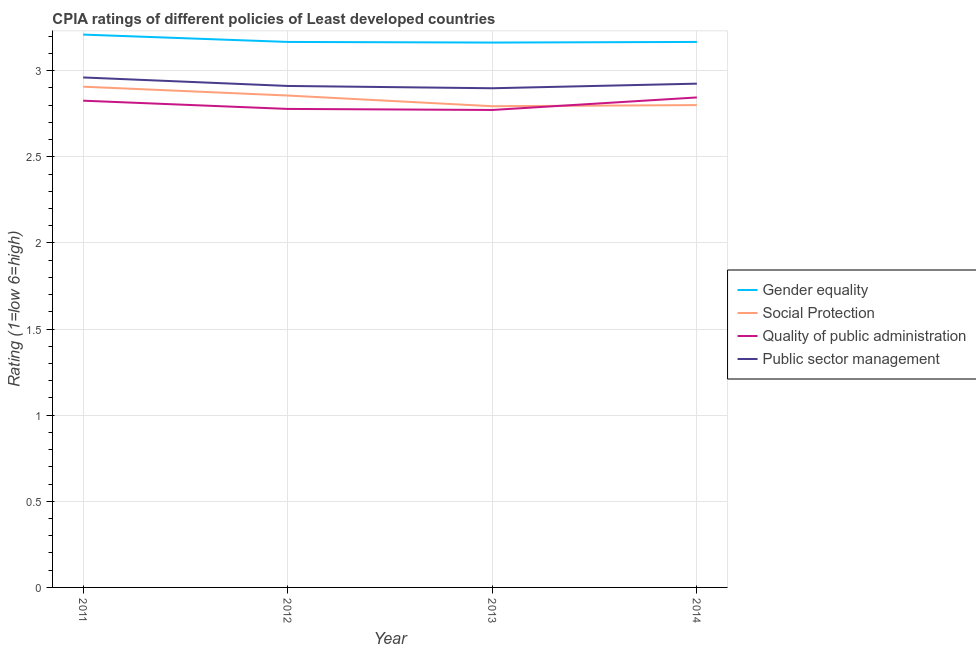Is the number of lines equal to the number of legend labels?
Make the answer very short. Yes. What is the cpia rating of quality of public administration in 2014?
Offer a terse response. 2.84. Across all years, what is the maximum cpia rating of social protection?
Keep it short and to the point. 2.91. Across all years, what is the minimum cpia rating of social protection?
Your response must be concise. 2.79. What is the total cpia rating of gender equality in the graph?
Your answer should be compact. 12.71. What is the difference between the cpia rating of social protection in 2012 and that in 2014?
Keep it short and to the point. 0.06. What is the difference between the cpia rating of quality of public administration in 2011 and the cpia rating of social protection in 2012?
Provide a succinct answer. -0.03. What is the average cpia rating of social protection per year?
Give a very brief answer. 2.84. In the year 2013, what is the difference between the cpia rating of public sector management and cpia rating of social protection?
Make the answer very short. 0.1. In how many years, is the cpia rating of social protection greater than 1.2?
Offer a very short reply. 4. What is the ratio of the cpia rating of public sector management in 2012 to that in 2014?
Your answer should be very brief. 1. What is the difference between the highest and the second highest cpia rating of gender equality?
Your answer should be very brief. 0.04. What is the difference between the highest and the lowest cpia rating of social protection?
Your response must be concise. 0.11. Is the sum of the cpia rating of gender equality in 2013 and 2014 greater than the maximum cpia rating of public sector management across all years?
Provide a short and direct response. Yes. Is it the case that in every year, the sum of the cpia rating of gender equality and cpia rating of social protection is greater than the cpia rating of quality of public administration?
Offer a very short reply. Yes. How many lines are there?
Make the answer very short. 4. Are the values on the major ticks of Y-axis written in scientific E-notation?
Your response must be concise. No. Does the graph contain any zero values?
Give a very brief answer. No. Does the graph contain grids?
Your answer should be compact. Yes. Where does the legend appear in the graph?
Provide a succinct answer. Center right. How many legend labels are there?
Provide a succinct answer. 4. What is the title of the graph?
Provide a succinct answer. CPIA ratings of different policies of Least developed countries. What is the label or title of the X-axis?
Your answer should be very brief. Year. What is the label or title of the Y-axis?
Keep it short and to the point. Rating (1=low 6=high). What is the Rating (1=low 6=high) in Gender equality in 2011?
Make the answer very short. 3.21. What is the Rating (1=low 6=high) in Social Protection in 2011?
Ensure brevity in your answer.  2.91. What is the Rating (1=low 6=high) in Quality of public administration in 2011?
Offer a terse response. 2.83. What is the Rating (1=low 6=high) of Public sector management in 2011?
Make the answer very short. 2.96. What is the Rating (1=low 6=high) in Gender equality in 2012?
Give a very brief answer. 3.17. What is the Rating (1=low 6=high) of Social Protection in 2012?
Provide a succinct answer. 2.86. What is the Rating (1=low 6=high) of Quality of public administration in 2012?
Your answer should be very brief. 2.78. What is the Rating (1=low 6=high) of Public sector management in 2012?
Your answer should be compact. 2.91. What is the Rating (1=low 6=high) of Gender equality in 2013?
Provide a succinct answer. 3.16. What is the Rating (1=low 6=high) in Social Protection in 2013?
Give a very brief answer. 2.79. What is the Rating (1=low 6=high) of Quality of public administration in 2013?
Provide a succinct answer. 2.77. What is the Rating (1=low 6=high) of Public sector management in 2013?
Give a very brief answer. 2.9. What is the Rating (1=low 6=high) in Gender equality in 2014?
Your answer should be compact. 3.17. What is the Rating (1=low 6=high) of Quality of public administration in 2014?
Keep it short and to the point. 2.84. What is the Rating (1=low 6=high) in Public sector management in 2014?
Offer a very short reply. 2.92. Across all years, what is the maximum Rating (1=low 6=high) of Gender equality?
Ensure brevity in your answer.  3.21. Across all years, what is the maximum Rating (1=low 6=high) in Social Protection?
Offer a terse response. 2.91. Across all years, what is the maximum Rating (1=low 6=high) of Quality of public administration?
Ensure brevity in your answer.  2.84. Across all years, what is the maximum Rating (1=low 6=high) of Public sector management?
Provide a short and direct response. 2.96. Across all years, what is the minimum Rating (1=low 6=high) of Gender equality?
Offer a terse response. 3.16. Across all years, what is the minimum Rating (1=low 6=high) of Social Protection?
Offer a terse response. 2.79. Across all years, what is the minimum Rating (1=low 6=high) in Quality of public administration?
Offer a very short reply. 2.77. Across all years, what is the minimum Rating (1=low 6=high) in Public sector management?
Provide a short and direct response. 2.9. What is the total Rating (1=low 6=high) in Gender equality in the graph?
Give a very brief answer. 12.71. What is the total Rating (1=low 6=high) in Social Protection in the graph?
Give a very brief answer. 11.36. What is the total Rating (1=low 6=high) in Quality of public administration in the graph?
Give a very brief answer. 11.22. What is the total Rating (1=low 6=high) in Public sector management in the graph?
Your response must be concise. 11.69. What is the difference between the Rating (1=low 6=high) of Gender equality in 2011 and that in 2012?
Give a very brief answer. 0.04. What is the difference between the Rating (1=low 6=high) of Social Protection in 2011 and that in 2012?
Ensure brevity in your answer.  0.05. What is the difference between the Rating (1=low 6=high) of Quality of public administration in 2011 and that in 2012?
Keep it short and to the point. 0.05. What is the difference between the Rating (1=low 6=high) in Public sector management in 2011 and that in 2012?
Offer a very short reply. 0.05. What is the difference between the Rating (1=low 6=high) in Gender equality in 2011 and that in 2013?
Ensure brevity in your answer.  0.05. What is the difference between the Rating (1=low 6=high) of Social Protection in 2011 and that in 2013?
Ensure brevity in your answer.  0.11. What is the difference between the Rating (1=low 6=high) in Quality of public administration in 2011 and that in 2013?
Ensure brevity in your answer.  0.05. What is the difference between the Rating (1=low 6=high) of Public sector management in 2011 and that in 2013?
Provide a short and direct response. 0.06. What is the difference between the Rating (1=low 6=high) of Gender equality in 2011 and that in 2014?
Provide a short and direct response. 0.04. What is the difference between the Rating (1=low 6=high) of Social Protection in 2011 and that in 2014?
Offer a terse response. 0.11. What is the difference between the Rating (1=low 6=high) of Quality of public administration in 2011 and that in 2014?
Your answer should be very brief. -0.02. What is the difference between the Rating (1=low 6=high) in Public sector management in 2011 and that in 2014?
Your answer should be very brief. 0.04. What is the difference between the Rating (1=low 6=high) in Gender equality in 2012 and that in 2013?
Keep it short and to the point. 0. What is the difference between the Rating (1=low 6=high) in Social Protection in 2012 and that in 2013?
Offer a terse response. 0.06. What is the difference between the Rating (1=low 6=high) of Quality of public administration in 2012 and that in 2013?
Keep it short and to the point. 0.01. What is the difference between the Rating (1=low 6=high) of Public sector management in 2012 and that in 2013?
Your response must be concise. 0.01. What is the difference between the Rating (1=low 6=high) in Gender equality in 2012 and that in 2014?
Keep it short and to the point. 0. What is the difference between the Rating (1=low 6=high) of Social Protection in 2012 and that in 2014?
Provide a short and direct response. 0.06. What is the difference between the Rating (1=low 6=high) of Quality of public administration in 2012 and that in 2014?
Provide a succinct answer. -0.07. What is the difference between the Rating (1=low 6=high) of Public sector management in 2012 and that in 2014?
Your answer should be very brief. -0.01. What is the difference between the Rating (1=low 6=high) in Gender equality in 2013 and that in 2014?
Offer a terse response. -0. What is the difference between the Rating (1=low 6=high) of Social Protection in 2013 and that in 2014?
Your answer should be very brief. -0.01. What is the difference between the Rating (1=low 6=high) of Quality of public administration in 2013 and that in 2014?
Provide a short and direct response. -0.07. What is the difference between the Rating (1=low 6=high) in Public sector management in 2013 and that in 2014?
Ensure brevity in your answer.  -0.03. What is the difference between the Rating (1=low 6=high) in Gender equality in 2011 and the Rating (1=low 6=high) in Social Protection in 2012?
Your answer should be compact. 0.35. What is the difference between the Rating (1=low 6=high) of Gender equality in 2011 and the Rating (1=low 6=high) of Quality of public administration in 2012?
Keep it short and to the point. 0.43. What is the difference between the Rating (1=low 6=high) of Gender equality in 2011 and the Rating (1=low 6=high) of Public sector management in 2012?
Make the answer very short. 0.3. What is the difference between the Rating (1=low 6=high) of Social Protection in 2011 and the Rating (1=low 6=high) of Quality of public administration in 2012?
Your answer should be very brief. 0.13. What is the difference between the Rating (1=low 6=high) in Social Protection in 2011 and the Rating (1=low 6=high) in Public sector management in 2012?
Provide a succinct answer. -0. What is the difference between the Rating (1=low 6=high) of Quality of public administration in 2011 and the Rating (1=low 6=high) of Public sector management in 2012?
Make the answer very short. -0.09. What is the difference between the Rating (1=low 6=high) in Gender equality in 2011 and the Rating (1=low 6=high) in Social Protection in 2013?
Provide a succinct answer. 0.42. What is the difference between the Rating (1=low 6=high) of Gender equality in 2011 and the Rating (1=low 6=high) of Quality of public administration in 2013?
Make the answer very short. 0.44. What is the difference between the Rating (1=low 6=high) of Gender equality in 2011 and the Rating (1=low 6=high) of Public sector management in 2013?
Ensure brevity in your answer.  0.31. What is the difference between the Rating (1=low 6=high) in Social Protection in 2011 and the Rating (1=low 6=high) in Quality of public administration in 2013?
Give a very brief answer. 0.14. What is the difference between the Rating (1=low 6=high) in Social Protection in 2011 and the Rating (1=low 6=high) in Public sector management in 2013?
Give a very brief answer. 0.01. What is the difference between the Rating (1=low 6=high) of Quality of public administration in 2011 and the Rating (1=low 6=high) of Public sector management in 2013?
Your response must be concise. -0.07. What is the difference between the Rating (1=low 6=high) of Gender equality in 2011 and the Rating (1=low 6=high) of Social Protection in 2014?
Give a very brief answer. 0.41. What is the difference between the Rating (1=low 6=high) in Gender equality in 2011 and the Rating (1=low 6=high) in Quality of public administration in 2014?
Keep it short and to the point. 0.36. What is the difference between the Rating (1=low 6=high) in Gender equality in 2011 and the Rating (1=low 6=high) in Public sector management in 2014?
Keep it short and to the point. 0.28. What is the difference between the Rating (1=low 6=high) of Social Protection in 2011 and the Rating (1=low 6=high) of Quality of public administration in 2014?
Offer a terse response. 0.06. What is the difference between the Rating (1=low 6=high) of Social Protection in 2011 and the Rating (1=low 6=high) of Public sector management in 2014?
Provide a succinct answer. -0.02. What is the difference between the Rating (1=low 6=high) of Quality of public administration in 2011 and the Rating (1=low 6=high) of Public sector management in 2014?
Ensure brevity in your answer.  -0.1. What is the difference between the Rating (1=low 6=high) of Gender equality in 2012 and the Rating (1=low 6=high) of Social Protection in 2013?
Provide a short and direct response. 0.37. What is the difference between the Rating (1=low 6=high) of Gender equality in 2012 and the Rating (1=low 6=high) of Quality of public administration in 2013?
Give a very brief answer. 0.39. What is the difference between the Rating (1=low 6=high) in Gender equality in 2012 and the Rating (1=low 6=high) in Public sector management in 2013?
Provide a short and direct response. 0.27. What is the difference between the Rating (1=low 6=high) of Social Protection in 2012 and the Rating (1=low 6=high) of Quality of public administration in 2013?
Make the answer very short. 0.08. What is the difference between the Rating (1=low 6=high) of Social Protection in 2012 and the Rating (1=low 6=high) of Public sector management in 2013?
Offer a terse response. -0.04. What is the difference between the Rating (1=low 6=high) in Quality of public administration in 2012 and the Rating (1=low 6=high) in Public sector management in 2013?
Offer a terse response. -0.12. What is the difference between the Rating (1=low 6=high) in Gender equality in 2012 and the Rating (1=low 6=high) in Social Protection in 2014?
Your answer should be compact. 0.37. What is the difference between the Rating (1=low 6=high) of Gender equality in 2012 and the Rating (1=low 6=high) of Quality of public administration in 2014?
Your answer should be compact. 0.32. What is the difference between the Rating (1=low 6=high) of Gender equality in 2012 and the Rating (1=low 6=high) of Public sector management in 2014?
Give a very brief answer. 0.24. What is the difference between the Rating (1=low 6=high) in Social Protection in 2012 and the Rating (1=low 6=high) in Quality of public administration in 2014?
Make the answer very short. 0.01. What is the difference between the Rating (1=low 6=high) of Social Protection in 2012 and the Rating (1=low 6=high) of Public sector management in 2014?
Ensure brevity in your answer.  -0.07. What is the difference between the Rating (1=low 6=high) in Quality of public administration in 2012 and the Rating (1=low 6=high) in Public sector management in 2014?
Ensure brevity in your answer.  -0.15. What is the difference between the Rating (1=low 6=high) of Gender equality in 2013 and the Rating (1=low 6=high) of Social Protection in 2014?
Give a very brief answer. 0.36. What is the difference between the Rating (1=low 6=high) in Gender equality in 2013 and the Rating (1=low 6=high) in Quality of public administration in 2014?
Provide a succinct answer. 0.32. What is the difference between the Rating (1=low 6=high) of Gender equality in 2013 and the Rating (1=low 6=high) of Public sector management in 2014?
Make the answer very short. 0.24. What is the difference between the Rating (1=low 6=high) in Social Protection in 2013 and the Rating (1=low 6=high) in Quality of public administration in 2014?
Make the answer very short. -0.05. What is the difference between the Rating (1=low 6=high) of Social Protection in 2013 and the Rating (1=low 6=high) of Public sector management in 2014?
Keep it short and to the point. -0.13. What is the difference between the Rating (1=low 6=high) of Quality of public administration in 2013 and the Rating (1=low 6=high) of Public sector management in 2014?
Your answer should be very brief. -0.15. What is the average Rating (1=low 6=high) of Gender equality per year?
Your response must be concise. 3.18. What is the average Rating (1=low 6=high) of Social Protection per year?
Your answer should be compact. 2.84. What is the average Rating (1=low 6=high) of Quality of public administration per year?
Ensure brevity in your answer.  2.8. What is the average Rating (1=low 6=high) in Public sector management per year?
Provide a succinct answer. 2.92. In the year 2011, what is the difference between the Rating (1=low 6=high) of Gender equality and Rating (1=low 6=high) of Social Protection?
Keep it short and to the point. 0.3. In the year 2011, what is the difference between the Rating (1=low 6=high) of Gender equality and Rating (1=low 6=high) of Quality of public administration?
Keep it short and to the point. 0.38. In the year 2011, what is the difference between the Rating (1=low 6=high) of Gender equality and Rating (1=low 6=high) of Public sector management?
Offer a terse response. 0.25. In the year 2011, what is the difference between the Rating (1=low 6=high) of Social Protection and Rating (1=low 6=high) of Quality of public administration?
Ensure brevity in your answer.  0.08. In the year 2011, what is the difference between the Rating (1=low 6=high) of Social Protection and Rating (1=low 6=high) of Public sector management?
Your response must be concise. -0.05. In the year 2011, what is the difference between the Rating (1=low 6=high) in Quality of public administration and Rating (1=low 6=high) in Public sector management?
Offer a terse response. -0.13. In the year 2012, what is the difference between the Rating (1=low 6=high) in Gender equality and Rating (1=low 6=high) in Social Protection?
Your answer should be very brief. 0.31. In the year 2012, what is the difference between the Rating (1=low 6=high) in Gender equality and Rating (1=low 6=high) in Quality of public administration?
Ensure brevity in your answer.  0.39. In the year 2012, what is the difference between the Rating (1=low 6=high) of Gender equality and Rating (1=low 6=high) of Public sector management?
Provide a short and direct response. 0.26. In the year 2012, what is the difference between the Rating (1=low 6=high) in Social Protection and Rating (1=low 6=high) in Quality of public administration?
Provide a short and direct response. 0.08. In the year 2012, what is the difference between the Rating (1=low 6=high) of Social Protection and Rating (1=low 6=high) of Public sector management?
Ensure brevity in your answer.  -0.06. In the year 2012, what is the difference between the Rating (1=low 6=high) of Quality of public administration and Rating (1=low 6=high) of Public sector management?
Ensure brevity in your answer.  -0.13. In the year 2013, what is the difference between the Rating (1=low 6=high) in Gender equality and Rating (1=low 6=high) in Social Protection?
Give a very brief answer. 0.37. In the year 2013, what is the difference between the Rating (1=low 6=high) of Gender equality and Rating (1=low 6=high) of Quality of public administration?
Offer a very short reply. 0.39. In the year 2013, what is the difference between the Rating (1=low 6=high) of Gender equality and Rating (1=low 6=high) of Public sector management?
Provide a short and direct response. 0.27. In the year 2013, what is the difference between the Rating (1=low 6=high) of Social Protection and Rating (1=low 6=high) of Quality of public administration?
Provide a short and direct response. 0.02. In the year 2013, what is the difference between the Rating (1=low 6=high) of Social Protection and Rating (1=low 6=high) of Public sector management?
Your answer should be compact. -0.1. In the year 2013, what is the difference between the Rating (1=low 6=high) in Quality of public administration and Rating (1=low 6=high) in Public sector management?
Offer a terse response. -0.13. In the year 2014, what is the difference between the Rating (1=low 6=high) of Gender equality and Rating (1=low 6=high) of Social Protection?
Provide a succinct answer. 0.37. In the year 2014, what is the difference between the Rating (1=low 6=high) of Gender equality and Rating (1=low 6=high) of Quality of public administration?
Provide a succinct answer. 0.32. In the year 2014, what is the difference between the Rating (1=low 6=high) in Gender equality and Rating (1=low 6=high) in Public sector management?
Make the answer very short. 0.24. In the year 2014, what is the difference between the Rating (1=low 6=high) in Social Protection and Rating (1=low 6=high) in Quality of public administration?
Provide a short and direct response. -0.04. In the year 2014, what is the difference between the Rating (1=low 6=high) in Social Protection and Rating (1=low 6=high) in Public sector management?
Your answer should be compact. -0.12. In the year 2014, what is the difference between the Rating (1=low 6=high) of Quality of public administration and Rating (1=low 6=high) of Public sector management?
Your response must be concise. -0.08. What is the ratio of the Rating (1=low 6=high) in Gender equality in 2011 to that in 2012?
Your response must be concise. 1.01. What is the ratio of the Rating (1=low 6=high) of Quality of public administration in 2011 to that in 2012?
Offer a terse response. 1.02. What is the ratio of the Rating (1=low 6=high) in Public sector management in 2011 to that in 2012?
Your answer should be compact. 1.02. What is the ratio of the Rating (1=low 6=high) in Gender equality in 2011 to that in 2013?
Provide a short and direct response. 1.01. What is the ratio of the Rating (1=low 6=high) in Social Protection in 2011 to that in 2013?
Offer a terse response. 1.04. What is the ratio of the Rating (1=low 6=high) of Quality of public administration in 2011 to that in 2013?
Give a very brief answer. 1.02. What is the ratio of the Rating (1=low 6=high) in Public sector management in 2011 to that in 2013?
Your response must be concise. 1.02. What is the ratio of the Rating (1=low 6=high) of Gender equality in 2011 to that in 2014?
Offer a very short reply. 1.01. What is the ratio of the Rating (1=low 6=high) in Social Protection in 2011 to that in 2014?
Offer a very short reply. 1.04. What is the ratio of the Rating (1=low 6=high) of Quality of public administration in 2011 to that in 2014?
Provide a short and direct response. 0.99. What is the ratio of the Rating (1=low 6=high) of Public sector management in 2011 to that in 2014?
Offer a terse response. 1.01. What is the ratio of the Rating (1=low 6=high) of Social Protection in 2012 to that in 2013?
Your answer should be compact. 1.02. What is the ratio of the Rating (1=low 6=high) of Quality of public administration in 2012 to that in 2013?
Provide a short and direct response. 1. What is the ratio of the Rating (1=low 6=high) in Public sector management in 2012 to that in 2013?
Your answer should be very brief. 1. What is the ratio of the Rating (1=low 6=high) of Social Protection in 2012 to that in 2014?
Give a very brief answer. 1.02. What is the ratio of the Rating (1=low 6=high) in Quality of public administration in 2012 to that in 2014?
Give a very brief answer. 0.98. What is the ratio of the Rating (1=low 6=high) in Gender equality in 2013 to that in 2014?
Offer a very short reply. 1. What is the ratio of the Rating (1=low 6=high) in Quality of public administration in 2013 to that in 2014?
Your response must be concise. 0.97. What is the ratio of the Rating (1=low 6=high) of Public sector management in 2013 to that in 2014?
Your answer should be very brief. 0.99. What is the difference between the highest and the second highest Rating (1=low 6=high) in Gender equality?
Make the answer very short. 0.04. What is the difference between the highest and the second highest Rating (1=low 6=high) of Social Protection?
Provide a succinct answer. 0.05. What is the difference between the highest and the second highest Rating (1=low 6=high) of Quality of public administration?
Offer a terse response. 0.02. What is the difference between the highest and the second highest Rating (1=low 6=high) in Public sector management?
Your response must be concise. 0.04. What is the difference between the highest and the lowest Rating (1=low 6=high) in Gender equality?
Your answer should be very brief. 0.05. What is the difference between the highest and the lowest Rating (1=low 6=high) of Social Protection?
Provide a succinct answer. 0.11. What is the difference between the highest and the lowest Rating (1=low 6=high) in Quality of public administration?
Provide a short and direct response. 0.07. What is the difference between the highest and the lowest Rating (1=low 6=high) of Public sector management?
Ensure brevity in your answer.  0.06. 